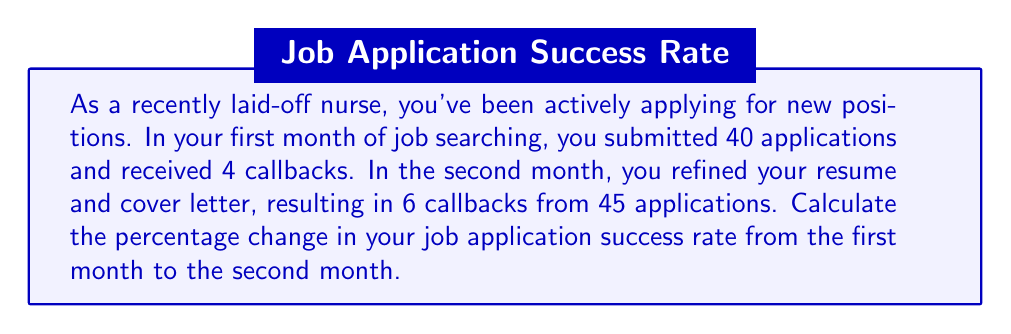Provide a solution to this math problem. To solve this problem, we need to follow these steps:

1. Calculate the success rate for each month:
   - Success rate = (Number of callbacks / Number of applications) × 100%

2. For the first month:
   $\text{Success rate}_1 = \frac{4}{40} \times 100\% = 10\%$

3. For the second month:
   $\text{Success rate}_2 = \frac{6}{45} \times 100\% = 13.33\%$

4. Calculate the percentage change using the formula:
   $\text{Percentage change} = \frac{\text{New value} - \text{Original value}}{\text{Original value}} \times 100\%$

5. Plug in the values:
   $$\text{Percentage change} = \frac{13.33\% - 10\%}{10\%} \times 100\%$$
   $$= \frac{3.33\%}{10\%} \times 100\%$$
   $$= 0.333 \times 100\%$$
   $$= 33.3\%$$

Therefore, the percentage change in your job application success rate from the first month to the second month is an increase of 33.3%.
Answer: The percentage change in job application success rate is an increase of 33.3%. 